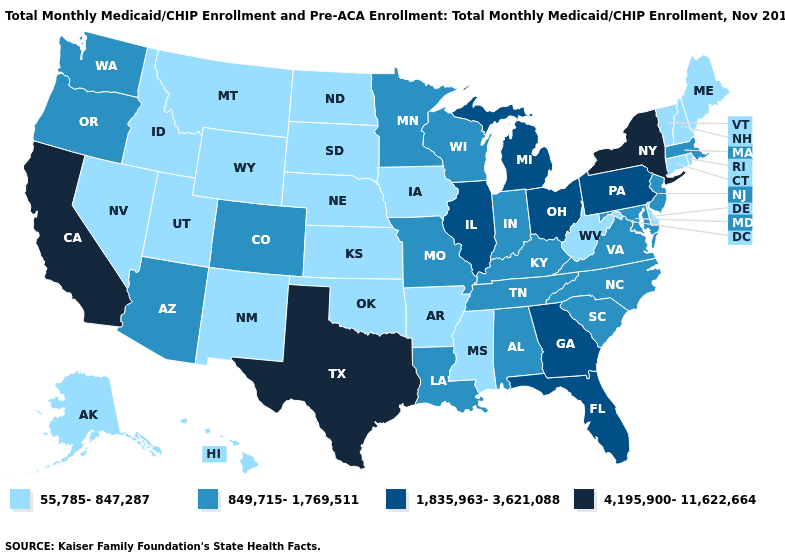Does the first symbol in the legend represent the smallest category?
Keep it brief. Yes. Does the first symbol in the legend represent the smallest category?
Concise answer only. Yes. What is the value of North Dakota?
Give a very brief answer. 55,785-847,287. What is the value of Georgia?
Concise answer only. 1,835,963-3,621,088. What is the value of Indiana?
Short answer required. 849,715-1,769,511. What is the highest value in states that border Idaho?
Short answer required. 849,715-1,769,511. Among the states that border Pennsylvania , does West Virginia have the lowest value?
Give a very brief answer. Yes. What is the highest value in states that border Kansas?
Keep it brief. 849,715-1,769,511. Does Michigan have the lowest value in the USA?
Write a very short answer. No. Name the states that have a value in the range 4,195,900-11,622,664?
Write a very short answer. California, New York, Texas. Which states hav the highest value in the South?
Keep it brief. Texas. Among the states that border Alabama , which have the lowest value?
Quick response, please. Mississippi. Does Alaska have a higher value than Wisconsin?
Give a very brief answer. No. Is the legend a continuous bar?
Concise answer only. No. What is the value of Alabama?
Quick response, please. 849,715-1,769,511. 